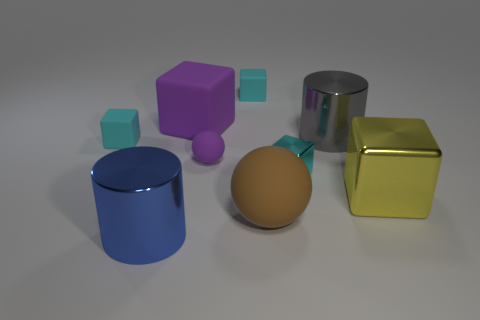There is another object that is the same shape as the large brown matte object; what is its color?
Keep it short and to the point. Purple. How many big rubber objects have the same color as the big matte cube?
Provide a succinct answer. 0. Are there more things that are behind the gray cylinder than small matte cylinders?
Your answer should be compact. Yes. There is a tiny rubber thing that is on the left side of the metallic cylinder in front of the big yellow shiny cube; what is its color?
Provide a short and direct response. Cyan. How many objects are things in front of the yellow metal thing or cylinders that are behind the brown matte object?
Ensure brevity in your answer.  3. What color is the tiny sphere?
Make the answer very short. Purple. What number of purple spheres have the same material as the yellow cube?
Provide a succinct answer. 0. Is the number of large brown rubber objects greater than the number of yellow balls?
Offer a very short reply. Yes. How many cyan objects are to the right of the cyan matte block that is to the left of the tiny purple ball?
Your answer should be very brief. 2. What number of objects are either blocks left of the gray shiny cylinder or brown objects?
Give a very brief answer. 5. 